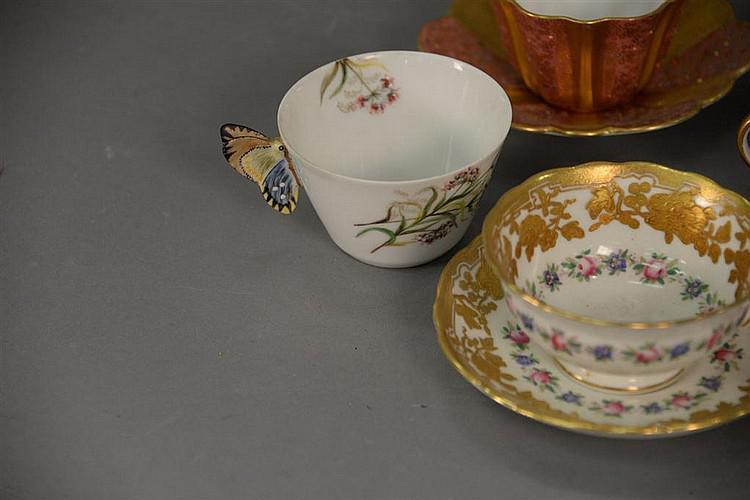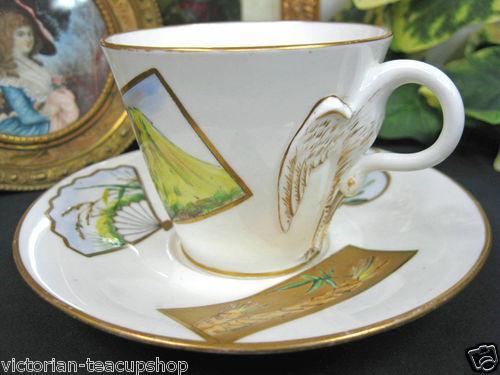The first image is the image on the left, the second image is the image on the right. Considering the images on both sides, is "One cup is not on a saucer." valid? Answer yes or no. Yes. 